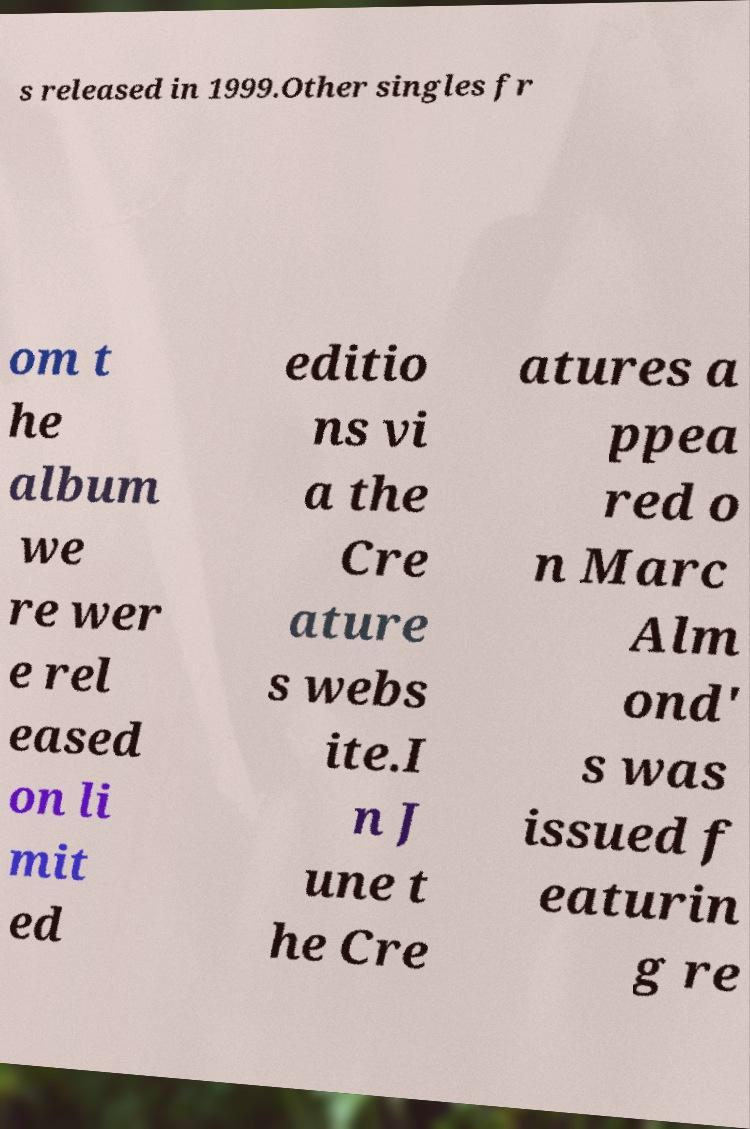Can you accurately transcribe the text from the provided image for me? s released in 1999.Other singles fr om t he album we re wer e rel eased on li mit ed editio ns vi a the Cre ature s webs ite.I n J une t he Cre atures a ppea red o n Marc Alm ond' s was issued f eaturin g re 